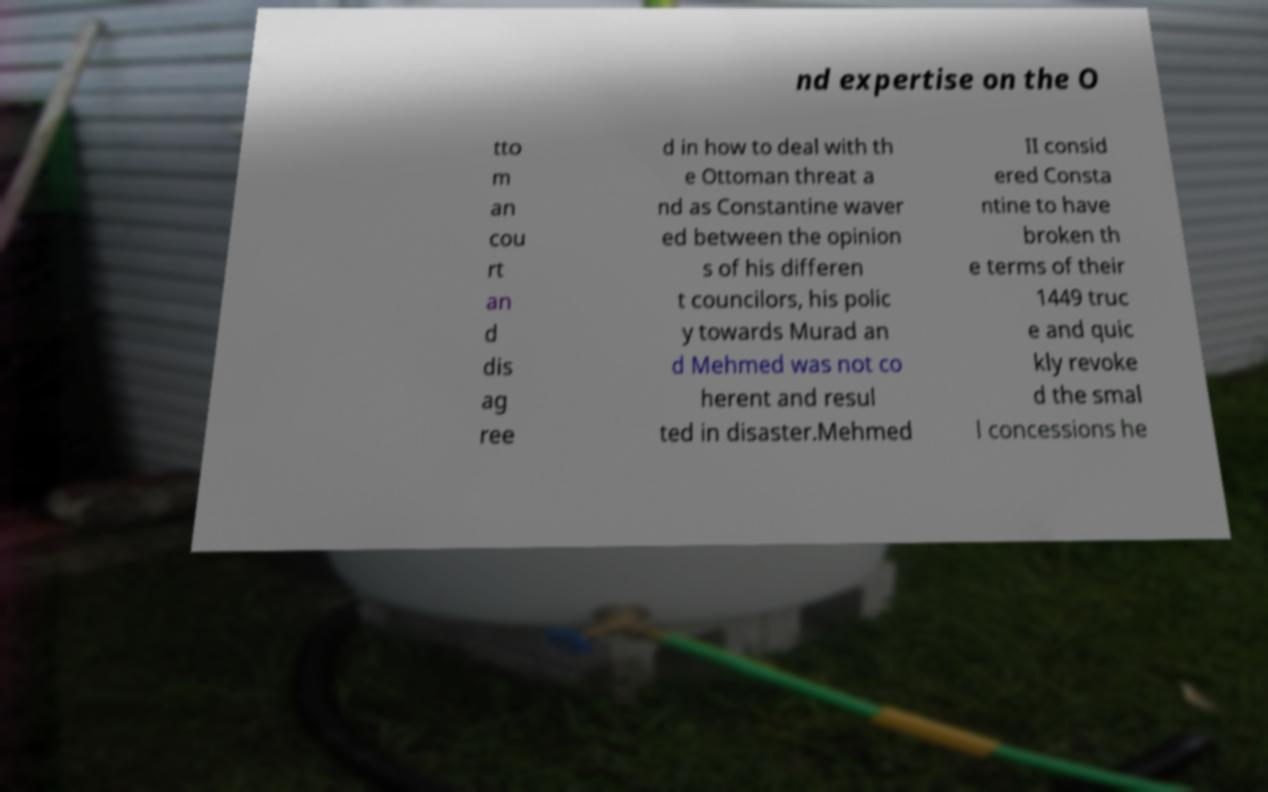For documentation purposes, I need the text within this image transcribed. Could you provide that? nd expertise on the O tto m an cou rt an d dis ag ree d in how to deal with th e Ottoman threat a nd as Constantine waver ed between the opinion s of his differen t councilors, his polic y towards Murad an d Mehmed was not co herent and resul ted in disaster.Mehmed II consid ered Consta ntine to have broken th e terms of their 1449 truc e and quic kly revoke d the smal l concessions he 